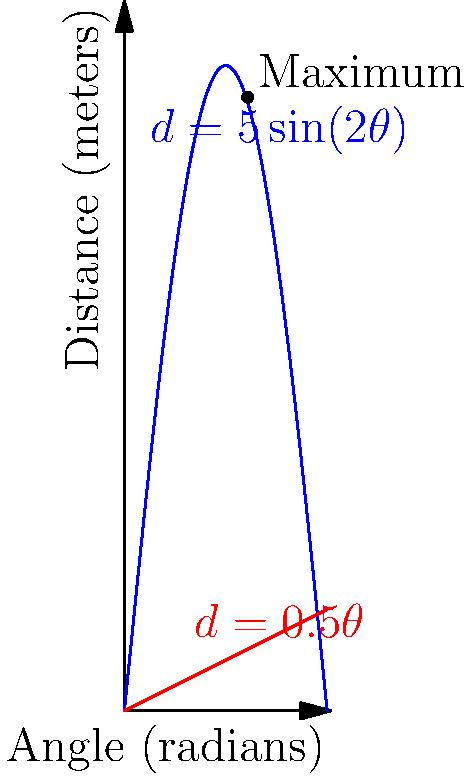Kobe Jones, one of your star athletes, is practicing for the long jump. You've been analyzing his jumps and noticed that the distance he achieves can be modeled by the function $d = 5\sin(2\theta)$, where $d$ is the distance in meters and $\theta$ is the takeoff angle in radians. What takeoff angle should Kobe aim for to achieve the maximum distance, and what is that maximum distance? To find the optimal angle and maximum distance:

1) The maximum of the function occurs where its derivative is zero.

2) Differentiate $d$ with respect to $\theta$:
   $$\frac{dd}{d\theta} = 5 \cdot 2 \cos(2\theta) = 10\cos(2\theta)$$

3) Set the derivative to zero and solve:
   $$10\cos(2\theta) = 0$$
   $$\cos(2\theta) = 0$$
   $$2\theta = \frac{\pi}{2}$$
   $$\theta = \frac{\pi}{4} = 45°$$

4) To find the maximum distance, substitute this angle into the original function:
   $$d = 5\sin(2 \cdot \frac{\pi}{4}) = 5\sin(\frac{\pi}{2}) = 5 \cdot 1 = 5$$

Therefore, Kobe should aim for a takeoff angle of 45° to achieve the maximum distance of 5 meters.
Answer: 45°, 5 meters 